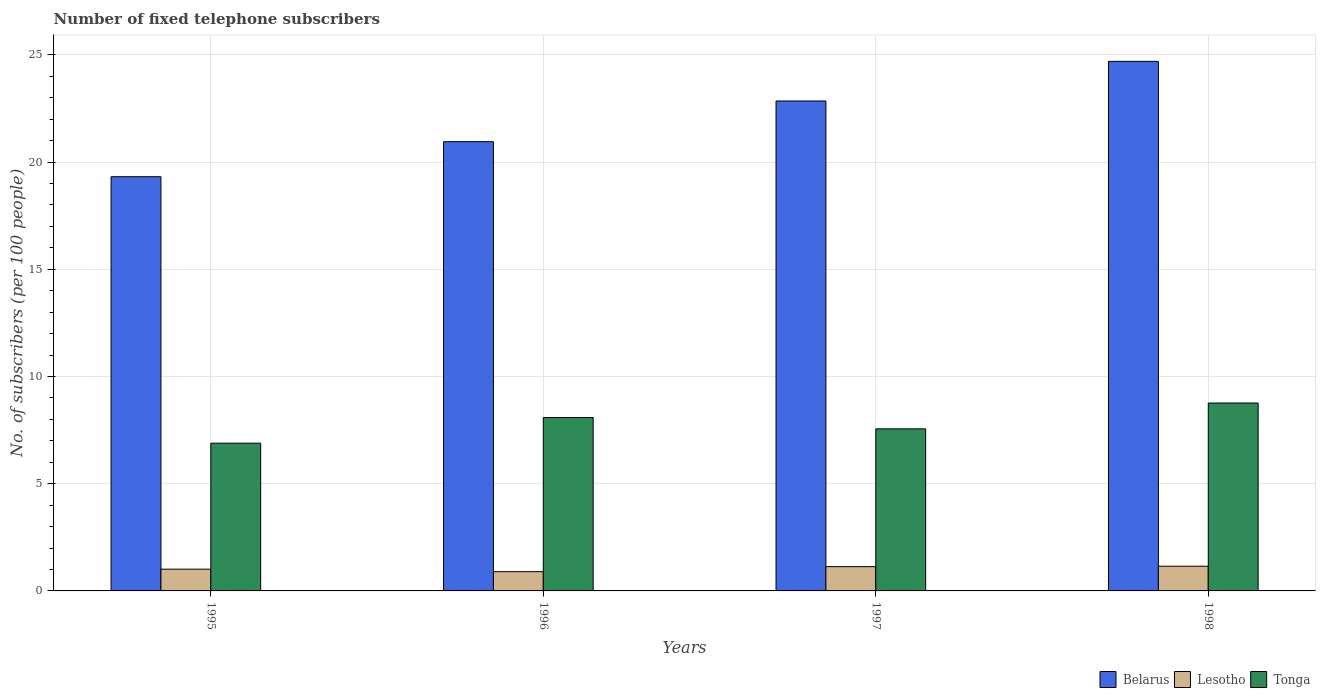Are the number of bars per tick equal to the number of legend labels?
Your response must be concise. Yes. Are the number of bars on each tick of the X-axis equal?
Give a very brief answer. Yes. How many bars are there on the 2nd tick from the left?
Your answer should be compact. 3. How many bars are there on the 3rd tick from the right?
Your response must be concise. 3. In how many cases, is the number of bars for a given year not equal to the number of legend labels?
Offer a terse response. 0. What is the number of fixed telephone subscribers in Lesotho in 1996?
Provide a succinct answer. 0.9. Across all years, what is the maximum number of fixed telephone subscribers in Tonga?
Provide a succinct answer. 8.76. Across all years, what is the minimum number of fixed telephone subscribers in Tonga?
Your response must be concise. 6.89. In which year was the number of fixed telephone subscribers in Lesotho maximum?
Your response must be concise. 1998. In which year was the number of fixed telephone subscribers in Tonga minimum?
Provide a short and direct response. 1995. What is the total number of fixed telephone subscribers in Tonga in the graph?
Give a very brief answer. 31.3. What is the difference between the number of fixed telephone subscribers in Lesotho in 1995 and that in 1996?
Provide a short and direct response. 0.12. What is the difference between the number of fixed telephone subscribers in Lesotho in 1998 and the number of fixed telephone subscribers in Tonga in 1995?
Make the answer very short. -5.74. What is the average number of fixed telephone subscribers in Belarus per year?
Provide a short and direct response. 21.96. In the year 1997, what is the difference between the number of fixed telephone subscribers in Belarus and number of fixed telephone subscribers in Lesotho?
Make the answer very short. 21.72. What is the ratio of the number of fixed telephone subscribers in Lesotho in 1995 to that in 1997?
Your answer should be very brief. 0.9. Is the difference between the number of fixed telephone subscribers in Belarus in 1995 and 1996 greater than the difference between the number of fixed telephone subscribers in Lesotho in 1995 and 1996?
Your response must be concise. No. What is the difference between the highest and the second highest number of fixed telephone subscribers in Lesotho?
Give a very brief answer. 0.02. What is the difference between the highest and the lowest number of fixed telephone subscribers in Tonga?
Keep it short and to the point. 1.87. What does the 3rd bar from the left in 1995 represents?
Make the answer very short. Tonga. What does the 2nd bar from the right in 1998 represents?
Offer a terse response. Lesotho. Is it the case that in every year, the sum of the number of fixed telephone subscribers in Tonga and number of fixed telephone subscribers in Belarus is greater than the number of fixed telephone subscribers in Lesotho?
Ensure brevity in your answer.  Yes. How many bars are there?
Your response must be concise. 12. How many years are there in the graph?
Your answer should be compact. 4. What is the difference between two consecutive major ticks on the Y-axis?
Make the answer very short. 5. Are the values on the major ticks of Y-axis written in scientific E-notation?
Your response must be concise. No. Does the graph contain grids?
Ensure brevity in your answer.  Yes. Where does the legend appear in the graph?
Provide a short and direct response. Bottom right. How are the legend labels stacked?
Keep it short and to the point. Horizontal. What is the title of the graph?
Offer a terse response. Number of fixed telephone subscribers. What is the label or title of the X-axis?
Give a very brief answer. Years. What is the label or title of the Y-axis?
Offer a terse response. No. of subscribers (per 100 people). What is the No. of subscribers (per 100 people) of Belarus in 1995?
Keep it short and to the point. 19.32. What is the No. of subscribers (per 100 people) of Lesotho in 1995?
Your response must be concise. 1.01. What is the No. of subscribers (per 100 people) in Tonga in 1995?
Provide a short and direct response. 6.89. What is the No. of subscribers (per 100 people) of Belarus in 1996?
Provide a short and direct response. 20.95. What is the No. of subscribers (per 100 people) of Lesotho in 1996?
Provide a short and direct response. 0.9. What is the No. of subscribers (per 100 people) of Tonga in 1996?
Your response must be concise. 8.09. What is the No. of subscribers (per 100 people) of Belarus in 1997?
Your answer should be very brief. 22.85. What is the No. of subscribers (per 100 people) of Lesotho in 1997?
Your answer should be compact. 1.13. What is the No. of subscribers (per 100 people) of Tonga in 1997?
Make the answer very short. 7.56. What is the No. of subscribers (per 100 people) of Belarus in 1998?
Give a very brief answer. 24.7. What is the No. of subscribers (per 100 people) of Lesotho in 1998?
Ensure brevity in your answer.  1.15. What is the No. of subscribers (per 100 people) in Tonga in 1998?
Make the answer very short. 8.76. Across all years, what is the maximum No. of subscribers (per 100 people) in Belarus?
Give a very brief answer. 24.7. Across all years, what is the maximum No. of subscribers (per 100 people) in Lesotho?
Provide a succinct answer. 1.15. Across all years, what is the maximum No. of subscribers (per 100 people) in Tonga?
Provide a succinct answer. 8.76. Across all years, what is the minimum No. of subscribers (per 100 people) in Belarus?
Keep it short and to the point. 19.32. Across all years, what is the minimum No. of subscribers (per 100 people) in Lesotho?
Offer a very short reply. 0.9. Across all years, what is the minimum No. of subscribers (per 100 people) in Tonga?
Your answer should be compact. 6.89. What is the total No. of subscribers (per 100 people) of Belarus in the graph?
Offer a very short reply. 87.82. What is the total No. of subscribers (per 100 people) in Lesotho in the graph?
Ensure brevity in your answer.  4.2. What is the total No. of subscribers (per 100 people) of Tonga in the graph?
Give a very brief answer. 31.3. What is the difference between the No. of subscribers (per 100 people) of Belarus in 1995 and that in 1996?
Keep it short and to the point. -1.63. What is the difference between the No. of subscribers (per 100 people) of Lesotho in 1995 and that in 1996?
Your answer should be compact. 0.12. What is the difference between the No. of subscribers (per 100 people) in Tonga in 1995 and that in 1996?
Your answer should be very brief. -1.2. What is the difference between the No. of subscribers (per 100 people) in Belarus in 1995 and that in 1997?
Provide a short and direct response. -3.53. What is the difference between the No. of subscribers (per 100 people) of Lesotho in 1995 and that in 1997?
Ensure brevity in your answer.  -0.12. What is the difference between the No. of subscribers (per 100 people) of Tonga in 1995 and that in 1997?
Your response must be concise. -0.67. What is the difference between the No. of subscribers (per 100 people) of Belarus in 1995 and that in 1998?
Offer a very short reply. -5.38. What is the difference between the No. of subscribers (per 100 people) of Lesotho in 1995 and that in 1998?
Your response must be concise. -0.14. What is the difference between the No. of subscribers (per 100 people) of Tonga in 1995 and that in 1998?
Provide a short and direct response. -1.87. What is the difference between the No. of subscribers (per 100 people) in Belarus in 1996 and that in 1997?
Keep it short and to the point. -1.9. What is the difference between the No. of subscribers (per 100 people) in Lesotho in 1996 and that in 1997?
Your answer should be compact. -0.23. What is the difference between the No. of subscribers (per 100 people) in Tonga in 1996 and that in 1997?
Your response must be concise. 0.53. What is the difference between the No. of subscribers (per 100 people) in Belarus in 1996 and that in 1998?
Your answer should be very brief. -3.75. What is the difference between the No. of subscribers (per 100 people) in Lesotho in 1996 and that in 1998?
Your response must be concise. -0.26. What is the difference between the No. of subscribers (per 100 people) in Tonga in 1996 and that in 1998?
Provide a short and direct response. -0.68. What is the difference between the No. of subscribers (per 100 people) of Belarus in 1997 and that in 1998?
Give a very brief answer. -1.85. What is the difference between the No. of subscribers (per 100 people) in Lesotho in 1997 and that in 1998?
Your response must be concise. -0.02. What is the difference between the No. of subscribers (per 100 people) in Tonga in 1997 and that in 1998?
Provide a short and direct response. -1.2. What is the difference between the No. of subscribers (per 100 people) of Belarus in 1995 and the No. of subscribers (per 100 people) of Lesotho in 1996?
Ensure brevity in your answer.  18.42. What is the difference between the No. of subscribers (per 100 people) in Belarus in 1995 and the No. of subscribers (per 100 people) in Tonga in 1996?
Offer a very short reply. 11.23. What is the difference between the No. of subscribers (per 100 people) of Lesotho in 1995 and the No. of subscribers (per 100 people) of Tonga in 1996?
Keep it short and to the point. -7.07. What is the difference between the No. of subscribers (per 100 people) of Belarus in 1995 and the No. of subscribers (per 100 people) of Lesotho in 1997?
Your answer should be very brief. 18.19. What is the difference between the No. of subscribers (per 100 people) of Belarus in 1995 and the No. of subscribers (per 100 people) of Tonga in 1997?
Your answer should be very brief. 11.76. What is the difference between the No. of subscribers (per 100 people) of Lesotho in 1995 and the No. of subscribers (per 100 people) of Tonga in 1997?
Offer a very short reply. -6.54. What is the difference between the No. of subscribers (per 100 people) in Belarus in 1995 and the No. of subscribers (per 100 people) in Lesotho in 1998?
Offer a very short reply. 18.17. What is the difference between the No. of subscribers (per 100 people) of Belarus in 1995 and the No. of subscribers (per 100 people) of Tonga in 1998?
Ensure brevity in your answer.  10.56. What is the difference between the No. of subscribers (per 100 people) of Lesotho in 1995 and the No. of subscribers (per 100 people) of Tonga in 1998?
Provide a short and direct response. -7.75. What is the difference between the No. of subscribers (per 100 people) of Belarus in 1996 and the No. of subscribers (per 100 people) of Lesotho in 1997?
Provide a short and direct response. 19.82. What is the difference between the No. of subscribers (per 100 people) in Belarus in 1996 and the No. of subscribers (per 100 people) in Tonga in 1997?
Ensure brevity in your answer.  13.39. What is the difference between the No. of subscribers (per 100 people) of Lesotho in 1996 and the No. of subscribers (per 100 people) of Tonga in 1997?
Your answer should be very brief. -6.66. What is the difference between the No. of subscribers (per 100 people) of Belarus in 1996 and the No. of subscribers (per 100 people) of Lesotho in 1998?
Make the answer very short. 19.8. What is the difference between the No. of subscribers (per 100 people) of Belarus in 1996 and the No. of subscribers (per 100 people) of Tonga in 1998?
Make the answer very short. 12.19. What is the difference between the No. of subscribers (per 100 people) of Lesotho in 1996 and the No. of subscribers (per 100 people) of Tonga in 1998?
Give a very brief answer. -7.87. What is the difference between the No. of subscribers (per 100 people) in Belarus in 1997 and the No. of subscribers (per 100 people) in Lesotho in 1998?
Your answer should be very brief. 21.7. What is the difference between the No. of subscribers (per 100 people) in Belarus in 1997 and the No. of subscribers (per 100 people) in Tonga in 1998?
Make the answer very short. 14.09. What is the difference between the No. of subscribers (per 100 people) of Lesotho in 1997 and the No. of subscribers (per 100 people) of Tonga in 1998?
Your answer should be very brief. -7.63. What is the average No. of subscribers (per 100 people) of Belarus per year?
Provide a succinct answer. 21.96. What is the average No. of subscribers (per 100 people) in Lesotho per year?
Give a very brief answer. 1.05. What is the average No. of subscribers (per 100 people) of Tonga per year?
Your response must be concise. 7.82. In the year 1995, what is the difference between the No. of subscribers (per 100 people) of Belarus and No. of subscribers (per 100 people) of Lesotho?
Keep it short and to the point. 18.3. In the year 1995, what is the difference between the No. of subscribers (per 100 people) of Belarus and No. of subscribers (per 100 people) of Tonga?
Give a very brief answer. 12.43. In the year 1995, what is the difference between the No. of subscribers (per 100 people) of Lesotho and No. of subscribers (per 100 people) of Tonga?
Provide a short and direct response. -5.88. In the year 1996, what is the difference between the No. of subscribers (per 100 people) of Belarus and No. of subscribers (per 100 people) of Lesotho?
Your answer should be very brief. 20.05. In the year 1996, what is the difference between the No. of subscribers (per 100 people) in Belarus and No. of subscribers (per 100 people) in Tonga?
Your response must be concise. 12.87. In the year 1996, what is the difference between the No. of subscribers (per 100 people) in Lesotho and No. of subscribers (per 100 people) in Tonga?
Your answer should be very brief. -7.19. In the year 1997, what is the difference between the No. of subscribers (per 100 people) of Belarus and No. of subscribers (per 100 people) of Lesotho?
Your response must be concise. 21.72. In the year 1997, what is the difference between the No. of subscribers (per 100 people) of Belarus and No. of subscribers (per 100 people) of Tonga?
Provide a short and direct response. 15.29. In the year 1997, what is the difference between the No. of subscribers (per 100 people) of Lesotho and No. of subscribers (per 100 people) of Tonga?
Offer a very short reply. -6.43. In the year 1998, what is the difference between the No. of subscribers (per 100 people) in Belarus and No. of subscribers (per 100 people) in Lesotho?
Your answer should be compact. 23.55. In the year 1998, what is the difference between the No. of subscribers (per 100 people) in Belarus and No. of subscribers (per 100 people) in Tonga?
Your answer should be very brief. 15.94. In the year 1998, what is the difference between the No. of subscribers (per 100 people) in Lesotho and No. of subscribers (per 100 people) in Tonga?
Your response must be concise. -7.61. What is the ratio of the No. of subscribers (per 100 people) of Belarus in 1995 to that in 1996?
Make the answer very short. 0.92. What is the ratio of the No. of subscribers (per 100 people) of Lesotho in 1995 to that in 1996?
Provide a short and direct response. 1.13. What is the ratio of the No. of subscribers (per 100 people) in Tonga in 1995 to that in 1996?
Provide a short and direct response. 0.85. What is the ratio of the No. of subscribers (per 100 people) in Belarus in 1995 to that in 1997?
Provide a short and direct response. 0.85. What is the ratio of the No. of subscribers (per 100 people) in Lesotho in 1995 to that in 1997?
Provide a short and direct response. 0.9. What is the ratio of the No. of subscribers (per 100 people) in Tonga in 1995 to that in 1997?
Your response must be concise. 0.91. What is the ratio of the No. of subscribers (per 100 people) in Belarus in 1995 to that in 1998?
Your answer should be very brief. 0.78. What is the ratio of the No. of subscribers (per 100 people) in Lesotho in 1995 to that in 1998?
Make the answer very short. 0.88. What is the ratio of the No. of subscribers (per 100 people) in Tonga in 1995 to that in 1998?
Your response must be concise. 0.79. What is the ratio of the No. of subscribers (per 100 people) in Belarus in 1996 to that in 1997?
Offer a terse response. 0.92. What is the ratio of the No. of subscribers (per 100 people) in Lesotho in 1996 to that in 1997?
Keep it short and to the point. 0.79. What is the ratio of the No. of subscribers (per 100 people) in Tonga in 1996 to that in 1997?
Provide a succinct answer. 1.07. What is the ratio of the No. of subscribers (per 100 people) of Belarus in 1996 to that in 1998?
Provide a succinct answer. 0.85. What is the ratio of the No. of subscribers (per 100 people) in Lesotho in 1996 to that in 1998?
Offer a very short reply. 0.78. What is the ratio of the No. of subscribers (per 100 people) of Tonga in 1996 to that in 1998?
Provide a succinct answer. 0.92. What is the ratio of the No. of subscribers (per 100 people) in Belarus in 1997 to that in 1998?
Provide a succinct answer. 0.93. What is the ratio of the No. of subscribers (per 100 people) in Lesotho in 1997 to that in 1998?
Your answer should be very brief. 0.98. What is the ratio of the No. of subscribers (per 100 people) in Tonga in 1997 to that in 1998?
Keep it short and to the point. 0.86. What is the difference between the highest and the second highest No. of subscribers (per 100 people) in Belarus?
Your answer should be very brief. 1.85. What is the difference between the highest and the second highest No. of subscribers (per 100 people) in Lesotho?
Offer a very short reply. 0.02. What is the difference between the highest and the second highest No. of subscribers (per 100 people) of Tonga?
Make the answer very short. 0.68. What is the difference between the highest and the lowest No. of subscribers (per 100 people) in Belarus?
Your answer should be very brief. 5.38. What is the difference between the highest and the lowest No. of subscribers (per 100 people) of Lesotho?
Make the answer very short. 0.26. What is the difference between the highest and the lowest No. of subscribers (per 100 people) of Tonga?
Give a very brief answer. 1.87. 